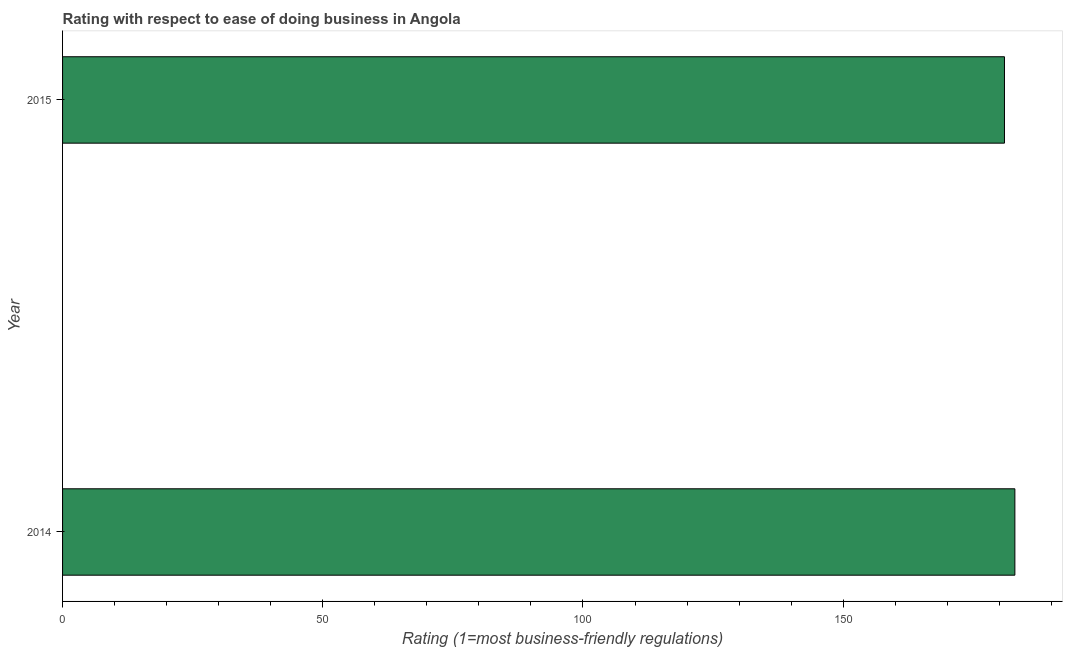Does the graph contain grids?
Ensure brevity in your answer.  No. What is the title of the graph?
Offer a terse response. Rating with respect to ease of doing business in Angola. What is the label or title of the X-axis?
Make the answer very short. Rating (1=most business-friendly regulations). What is the label or title of the Y-axis?
Offer a terse response. Year. What is the ease of doing business index in 2014?
Give a very brief answer. 183. Across all years, what is the maximum ease of doing business index?
Your response must be concise. 183. Across all years, what is the minimum ease of doing business index?
Provide a succinct answer. 181. In which year was the ease of doing business index maximum?
Offer a very short reply. 2014. In which year was the ease of doing business index minimum?
Your answer should be compact. 2015. What is the sum of the ease of doing business index?
Provide a short and direct response. 364. What is the average ease of doing business index per year?
Ensure brevity in your answer.  182. What is the median ease of doing business index?
Provide a succinct answer. 182. In how many years, is the ease of doing business index greater than 180 ?
Make the answer very short. 2. What is the ratio of the ease of doing business index in 2014 to that in 2015?
Offer a terse response. 1.01. Are all the bars in the graph horizontal?
Offer a very short reply. Yes. What is the difference between two consecutive major ticks on the X-axis?
Give a very brief answer. 50. What is the Rating (1=most business-friendly regulations) in 2014?
Your response must be concise. 183. What is the Rating (1=most business-friendly regulations) in 2015?
Ensure brevity in your answer.  181. What is the difference between the Rating (1=most business-friendly regulations) in 2014 and 2015?
Provide a succinct answer. 2. 